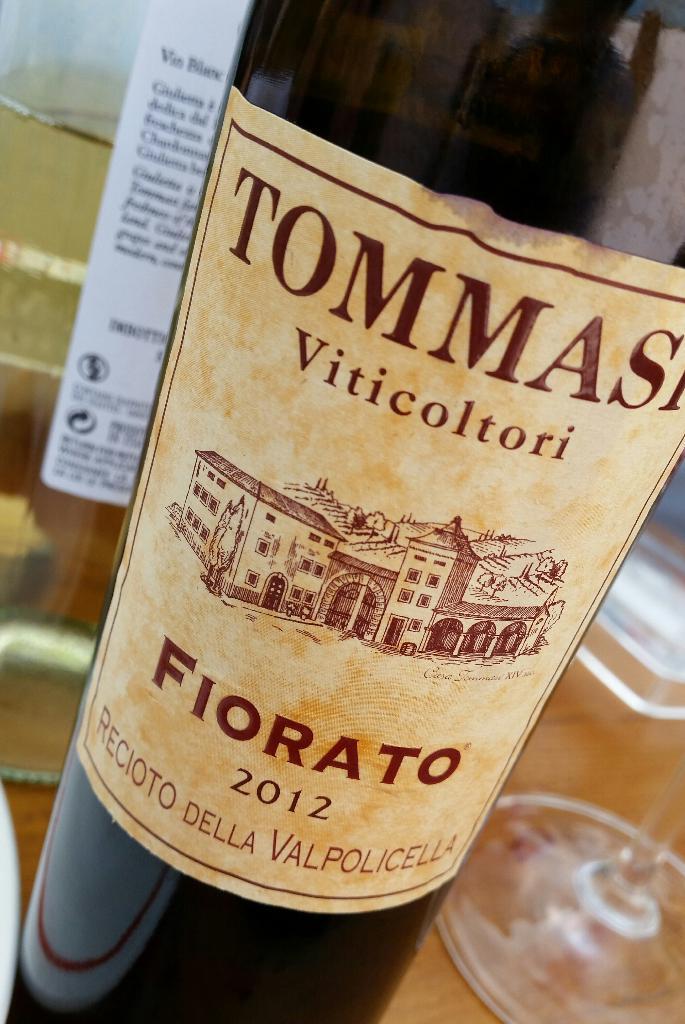What is the drink called?
Ensure brevity in your answer.  Fiorato. 